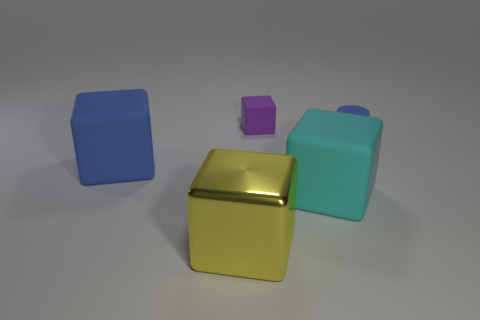Subtract 2 blocks. How many blocks are left? 2 Subtract all blue cubes. How many cubes are left? 3 Subtract all large cubes. How many cubes are left? 1 Add 4 yellow metal cubes. How many objects exist? 9 Subtract all green cubes. Subtract all purple spheres. How many cubes are left? 4 Subtract all cylinders. How many objects are left? 4 Add 1 large cyan shiny cylinders. How many large cyan shiny cylinders exist? 1 Subtract 0 brown balls. How many objects are left? 5 Subtract all purple rubber objects. Subtract all tiny rubber cylinders. How many objects are left? 3 Add 3 large cubes. How many large cubes are left? 6 